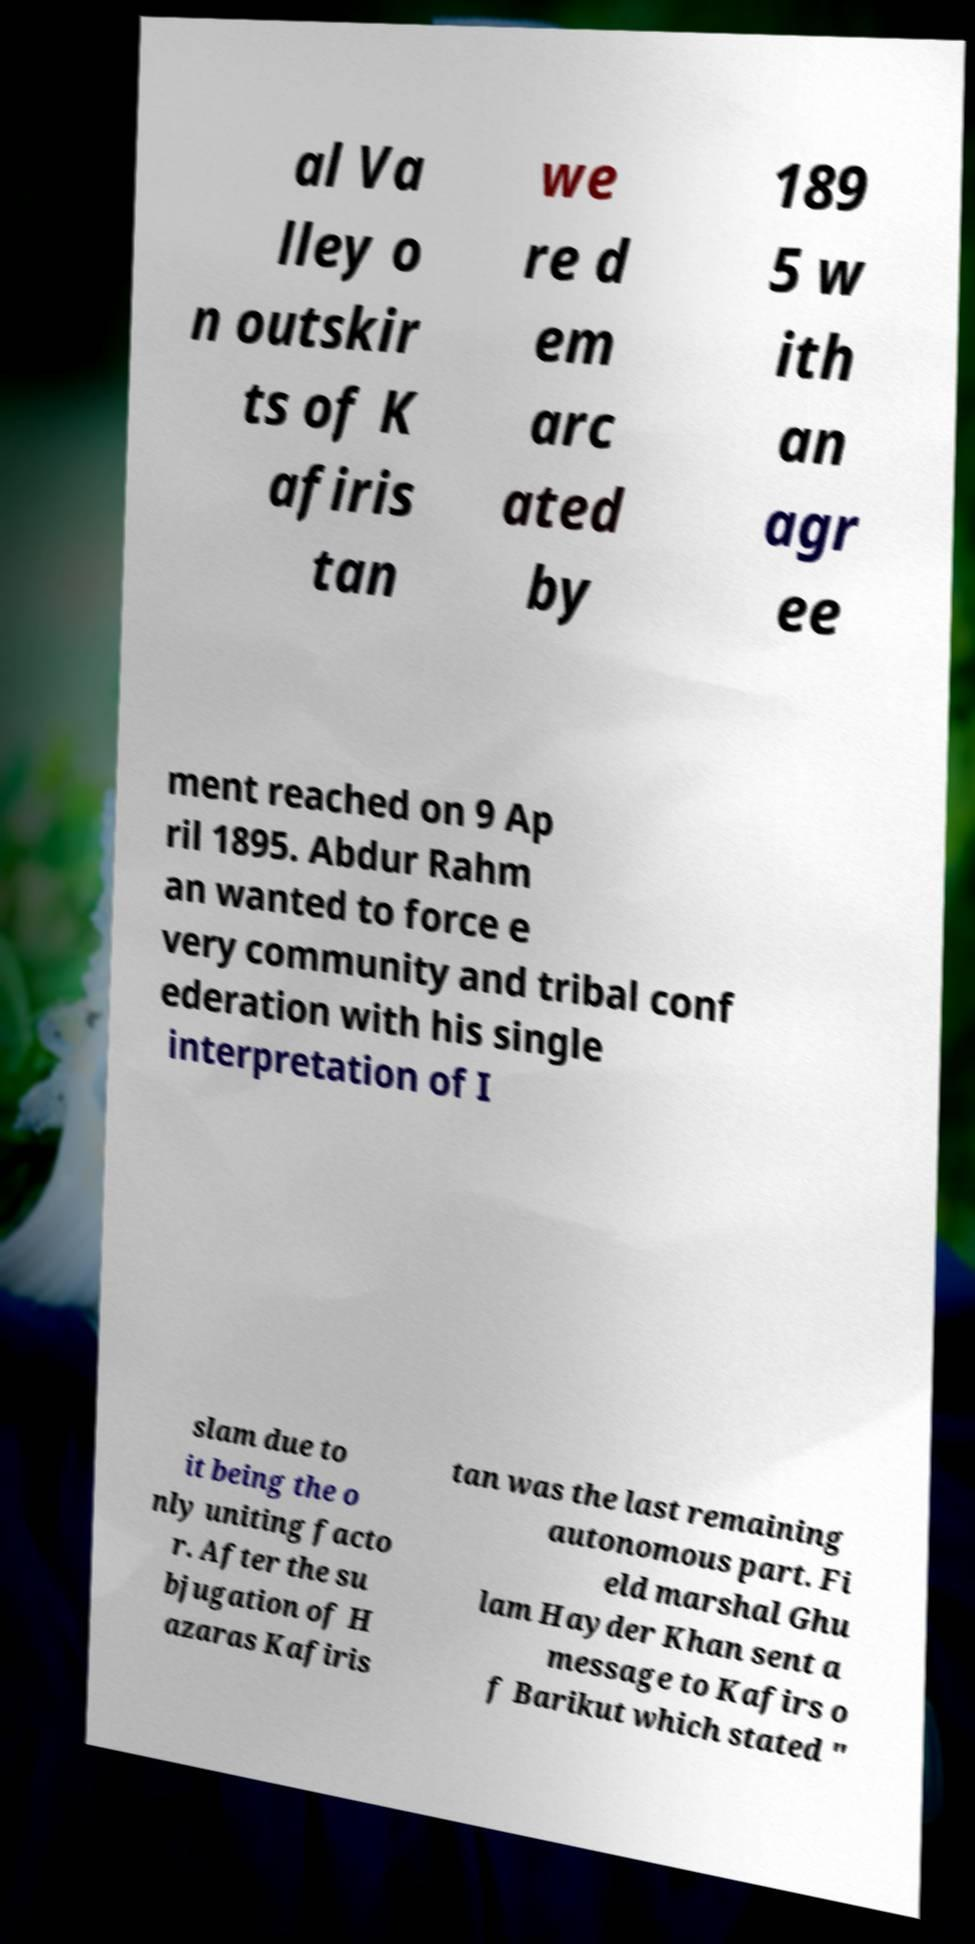Could you assist in decoding the text presented in this image and type it out clearly? al Va lley o n outskir ts of K afiris tan we re d em arc ated by 189 5 w ith an agr ee ment reached on 9 Ap ril 1895. Abdur Rahm an wanted to force e very community and tribal conf ederation with his single interpretation of I slam due to it being the o nly uniting facto r. After the su bjugation of H azaras Kafiris tan was the last remaining autonomous part. Fi eld marshal Ghu lam Hayder Khan sent a message to Kafirs o f Barikut which stated " 